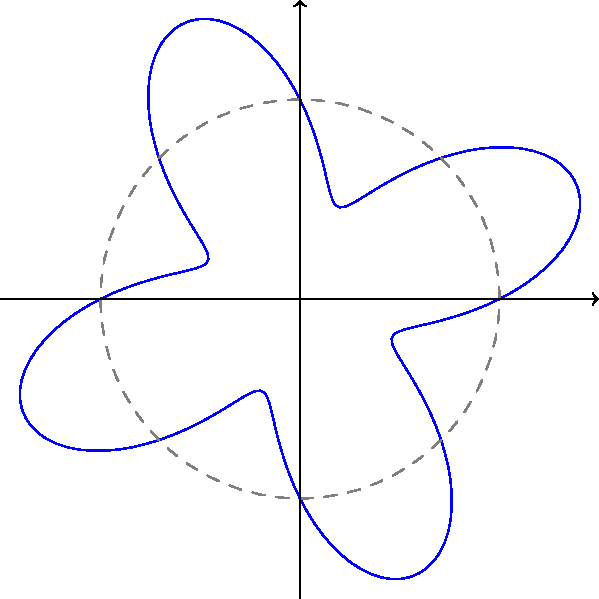In the context of enhancing pattern recognition abilities in early childhood education, consider the polar graph of the curve $r = 2 + \sin(4\theta)$. How many lines of symmetry does this flower-like curve have? To determine the number of lines of symmetry in this polar curve, we need to follow these steps:

1. Recognize the general form of the equation: $r = a + b\sin(n\theta)$ or $r = a + b\cos(n\theta)$, where $n$ is an integer.

2. In this case, we have $r = 2 + \sin(4\theta)$, so $a = 2$, $b = 1$, and $n = 4$.

3. For curves of this form, the number of lines of symmetry is determined by the value of $n$:
   - If $n$ is even, the number of lines of symmetry is $2n$.
   - If $n$ is odd, the number of lines of symmetry is $n$.

4. In our equation, $n = 4$, which is even.

5. Therefore, the number of lines of symmetry is $2n = 2(4) = 8$.

6. We can visually confirm this by observing that the curve has 8 "petals" and is symmetric about 8 equally spaced radial lines.

This type of pattern recognition exercise can help children develop spatial reasoning skills and understand geometric concepts like symmetry, which are crucial for early mathematical development.
Answer: 8 lines of symmetry 